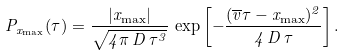Convert formula to latex. <formula><loc_0><loc_0><loc_500><loc_500>P _ { x _ { \max } } ( \tau ) = \frac { | x _ { \max } | } { \sqrt { 4 \pi \, D \, \tau ^ { 3 } } } \, \exp \left [ - \frac { ( \overline { v } \tau - x _ { \max } ) ^ { 2 } } { 4 \, D \, \tau } \right ] .</formula> 